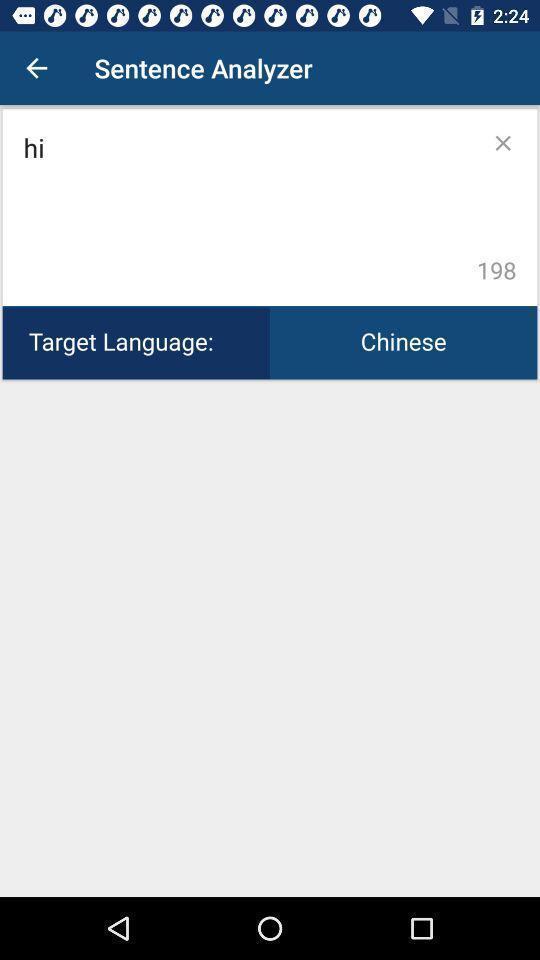Summarize the information in this screenshot. Screen displaying multiple options in a language translation application. 